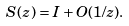<formula> <loc_0><loc_0><loc_500><loc_500>S ( z ) = I + O ( 1 / z ) .</formula> 